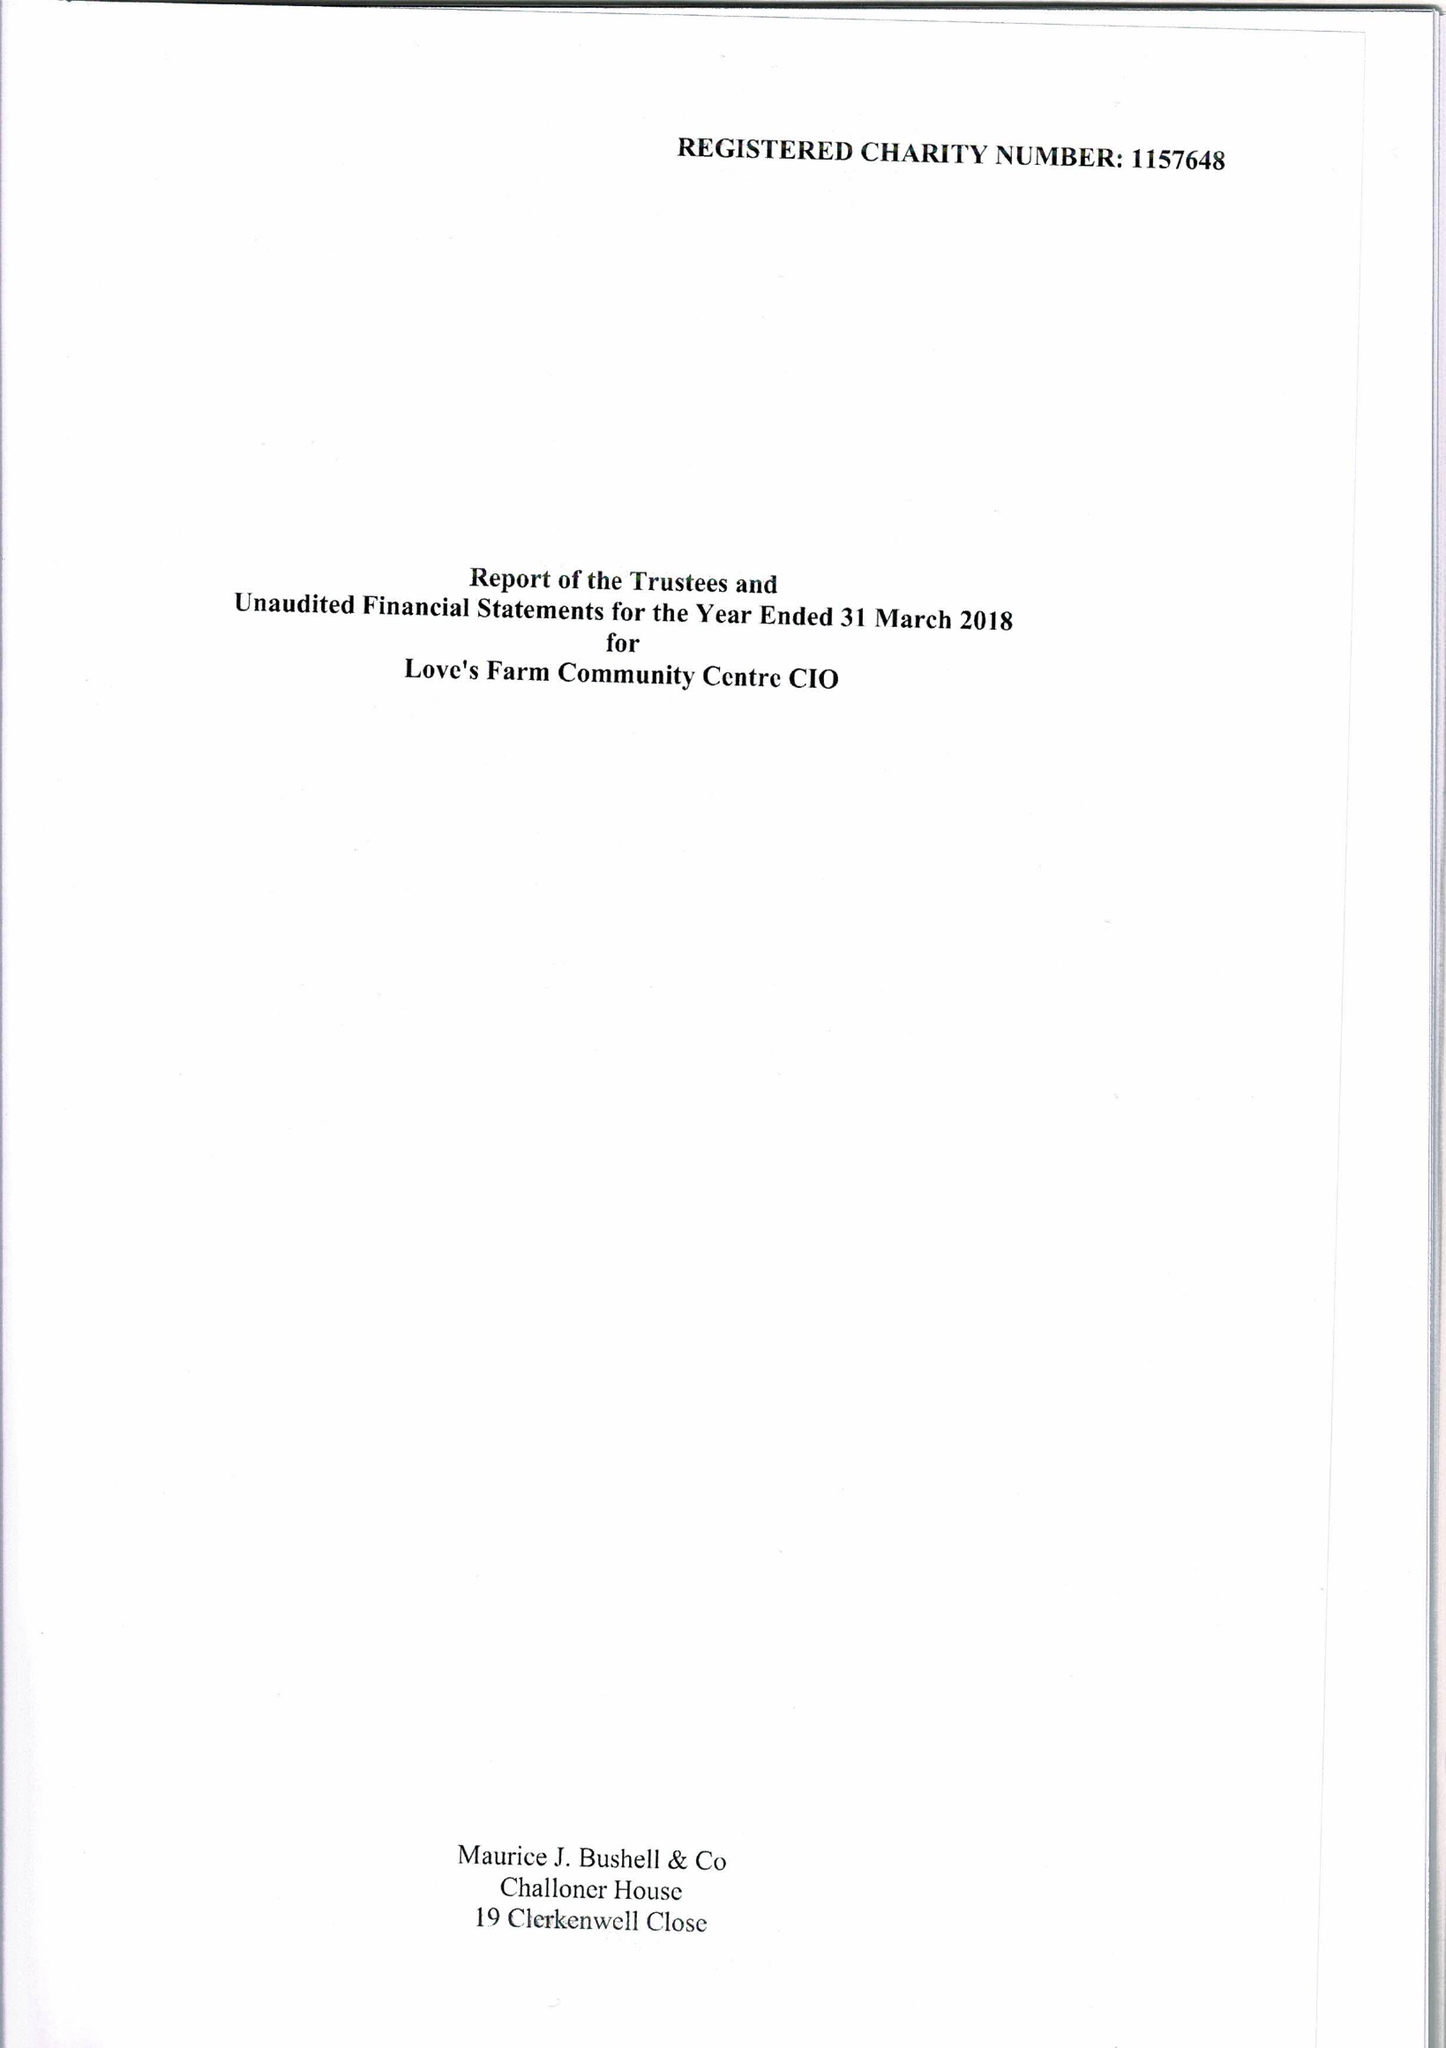What is the value for the address__post_town?
Answer the question using a single word or phrase. ST. NEOTS 